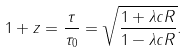Convert formula to latex. <formula><loc_0><loc_0><loc_500><loc_500>1 + z = \frac { \tau } { \tau _ { 0 } } = \sqrt { \frac { 1 + \lambda c R } { 1 - \lambda c R } } .</formula> 